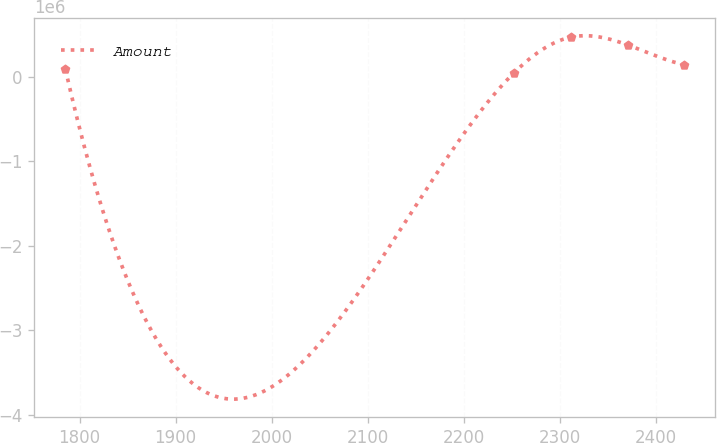<chart> <loc_0><loc_0><loc_500><loc_500><line_chart><ecel><fcel>Amount<nl><fcel>1785.22<fcel>88646.1<nl><fcel>2252.18<fcel>46601.8<nl><fcel>2311.22<fcel>467045<nl><fcel>2370.26<fcel>375689<nl><fcel>2429.3<fcel>140843<nl></chart> 